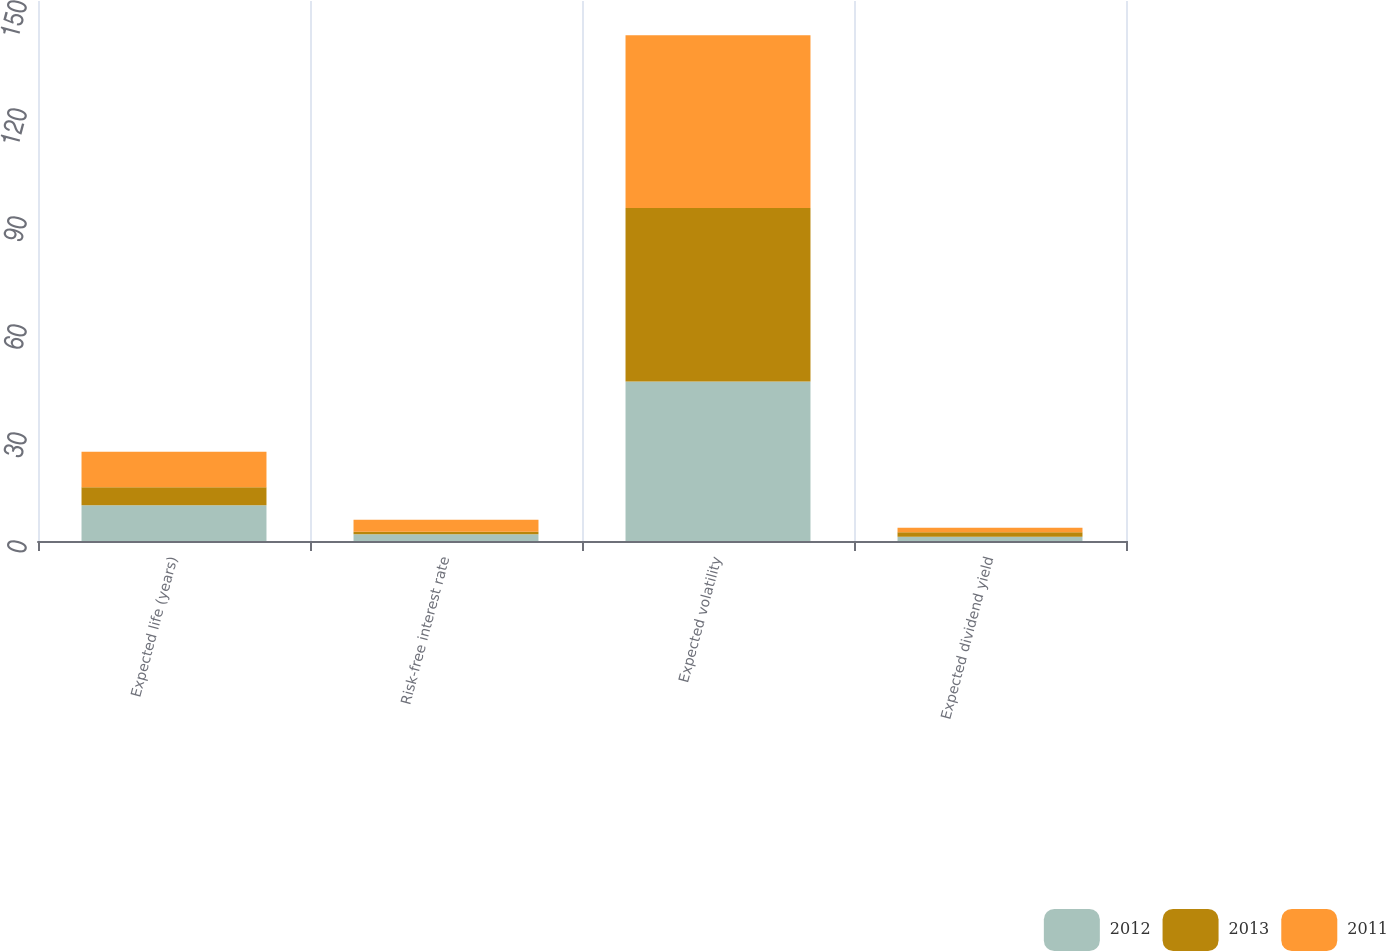<chart> <loc_0><loc_0><loc_500><loc_500><stacked_bar_chart><ecel><fcel>Expected life (years)<fcel>Risk-free interest rate<fcel>Expected volatility<fcel>Expected dividend yield<nl><fcel>2012<fcel>9.9<fcel>1.9<fcel>44.3<fcel>1.2<nl><fcel>2013<fcel>5<fcel>0.7<fcel>48.2<fcel>1.2<nl><fcel>2011<fcel>9.9<fcel>3.3<fcel>48<fcel>1.3<nl></chart> 